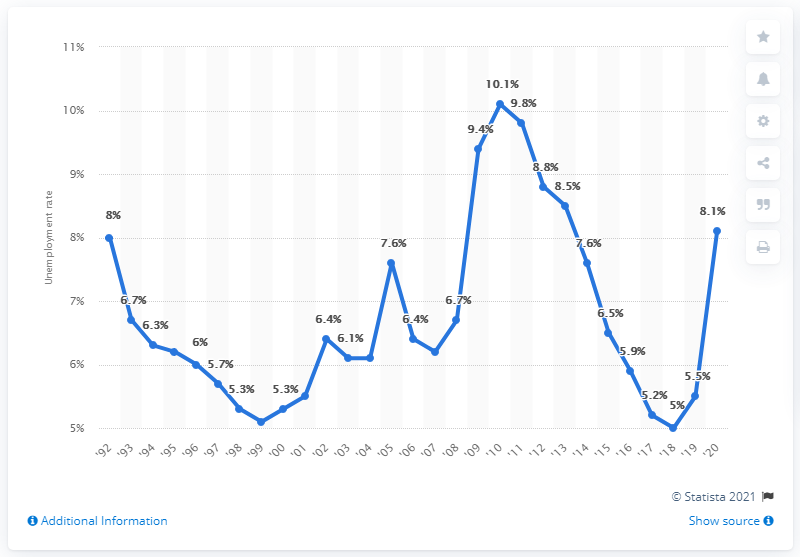Mention a couple of crucial points in this snapshot. In 2020, the unemployment rate in Mississippi was 8.1%. In 2010, Mississippi experienced its highest unemployment rate at 10.1%. 